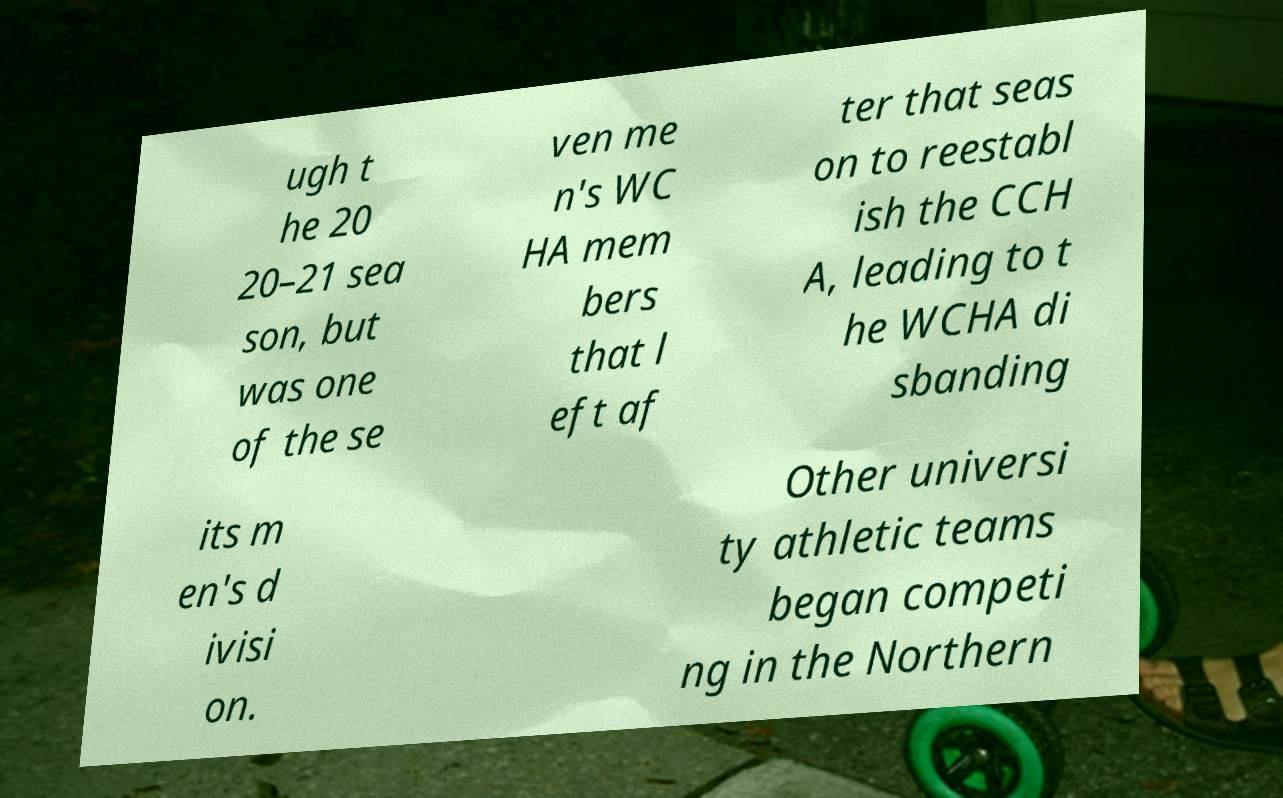What messages or text are displayed in this image? I need them in a readable, typed format. ugh t he 20 20–21 sea son, but was one of the se ven me n's WC HA mem bers that l eft af ter that seas on to reestabl ish the CCH A, leading to t he WCHA di sbanding its m en's d ivisi on. Other universi ty athletic teams began competi ng in the Northern 